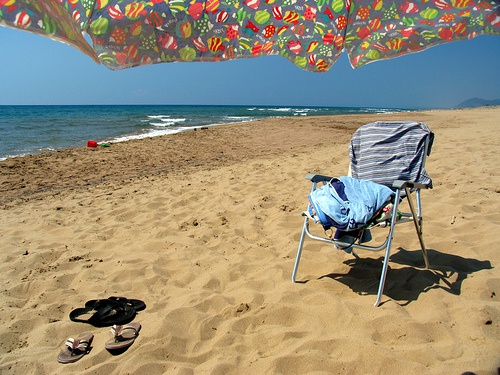Describe the objects in this image and their specific colors. I can see umbrella in brown, gray, and green tones, backpack in brown, lightblue, and navy tones, and chair in brown, gray, tan, black, and white tones in this image. 